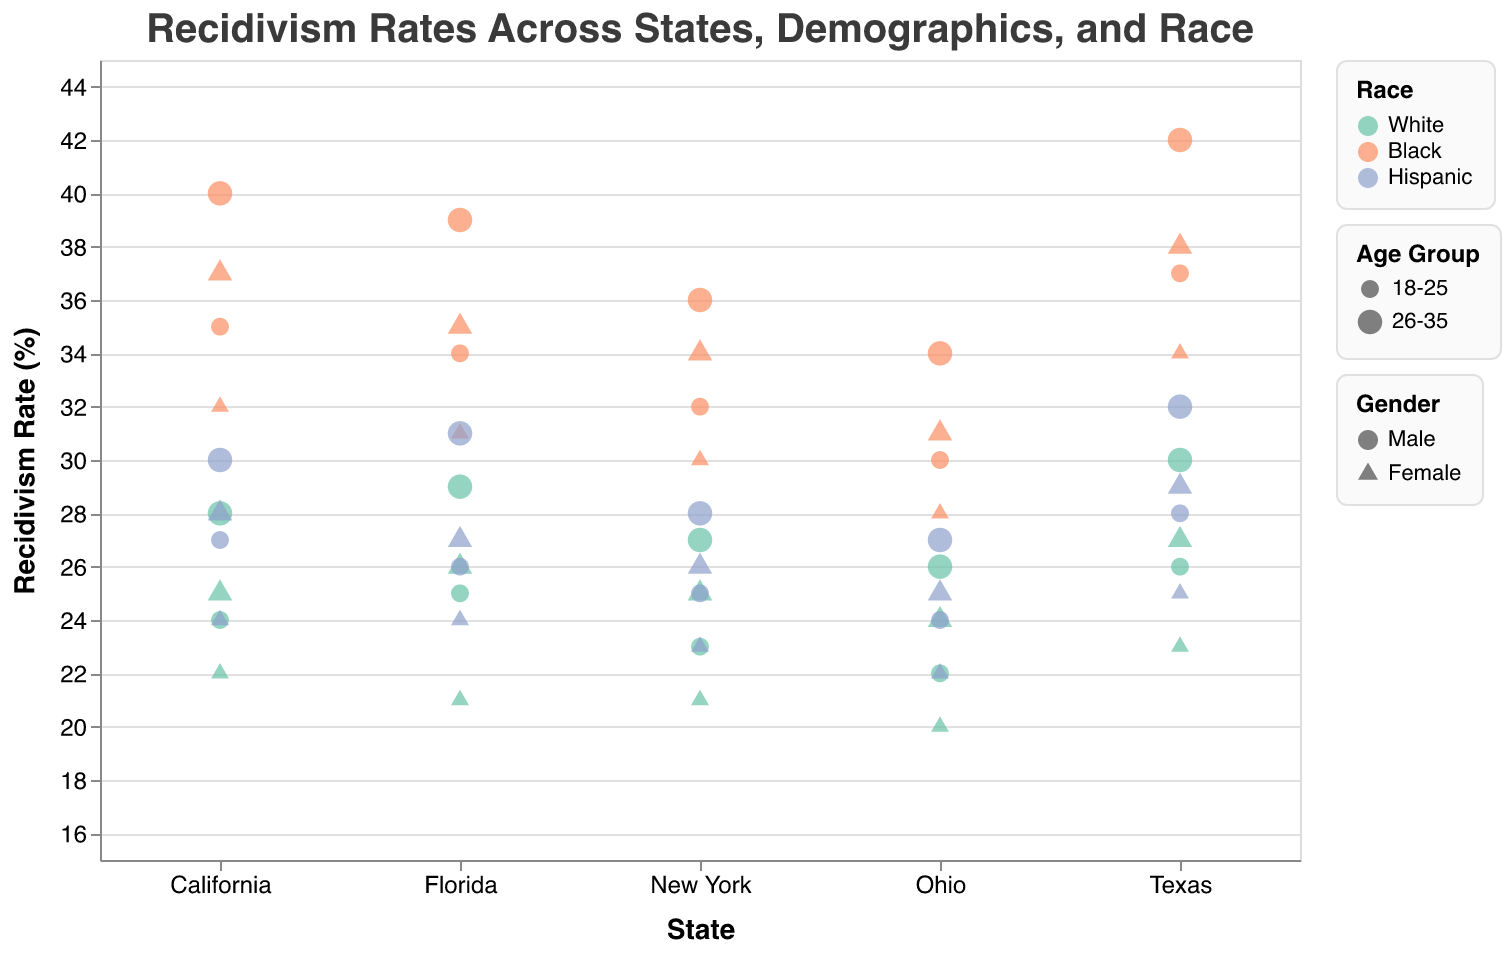What's the highest recidivism rate for Black males aged 26-35 across all states? Scan the plot for data points that represent Black males aged 26-35, looking for the highest position on the Recidivism Rate axis. Specifically, identify the color representing 'Black' and find the highest y-coordinate within the 'Black' data points.
Answer: 42 What's the difference in recidivism rates between 18-25 and 26-35 age groups for Hispanic females in California? Locate the data points representing Hispanic females in California with the respective age groups of 18-25 and 26-35. Identify their positions on the y-axis and subtract the lower age group's rate from the higher age group's rate.
Answer: 4 Which state has the lowest recidivism rate for White females aged 18-25? Identify the data points representing White females aged 18-25 across all states. Find the point lowest on the y-axis, corresponding to the lowest recidivism rate, and note the state.
Answer: Ohio What is the difference in recidivism rates between Hispanic males and females aged 26-35 in Texas? Identify the data points for Hispanic males and females aged 26-35 in Texas. Find their respective positions on the y-axis and subtract the female rate from the male rate.
Answer: 3 How does the recidivism rate for Black females aged 18-25 in New York compare to that of similar demographics in Florida? Find the points representing Black females aged 18-25 in both New York and Florida. Compare their y-axis positions to determine which state has a higher value.
Answer: New York Which race has the highest average recidivism rate in Florida? For each racial group in Florida, find all the respective points and calculate their average values on the Recidivism Rate axis. Compare these averages to determine which is the highest.
Answer: Black How much higher is the recidivism rate for Black males aged 18-25 compared to Hispanic males aged 18-25 in California? Locate the points for Black males aged 18-25 and Hispanic males aged 18-25 in California. Find their y-axis positions and subtract the lower rate from the higher rate.
Answer: 8 What is the average recidivism rate for all demographic groups in Ohio? Find all data points representing Ohio. Sum their y-axis values and divide by the number of points to get the average.
Answer: 26.08 Between Ohio and Texas, which state has a lower recidivism rate for White males aged 26-35? Identify the data points for White males aged 26-35 in both Ohio and Texas. Compare their positions on the y-axis and note which state has the lower value.
Answer: Ohio 